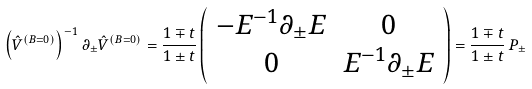<formula> <loc_0><loc_0><loc_500><loc_500>\left ( \hat { V } ^ { ( B = 0 ) } \right ) ^ { - 1 } \partial _ { \pm } \hat { V } ^ { ( B = 0 ) } = { \frac { 1 \mp t } { 1 \pm t } } \left ( \begin{array} { c c } { { - E ^ { - 1 } \partial _ { \pm } E } } & { 0 } \\ { 0 } & { { E ^ { - 1 } \partial _ { \pm } E } } \end{array} \right ) = { \frac { 1 \mp t } { 1 \pm t } } \, P _ { \pm }</formula> 